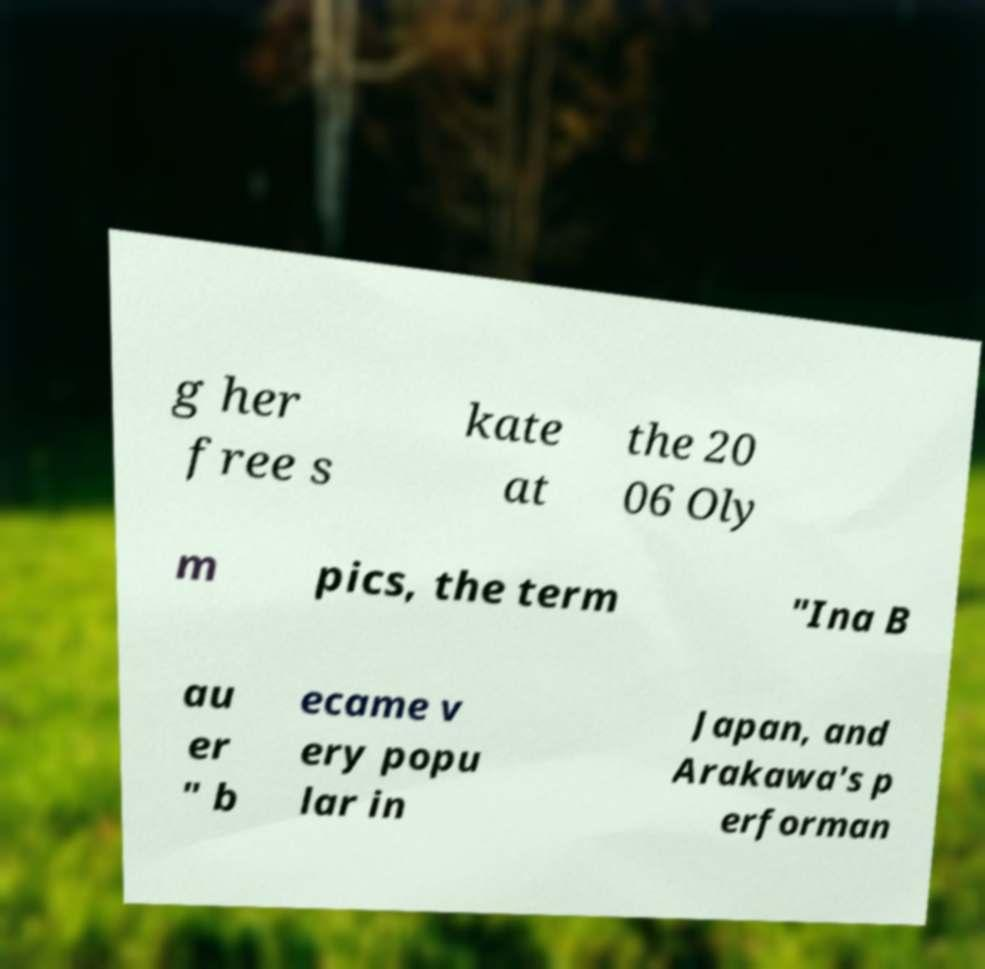Please read and relay the text visible in this image. What does it say? g her free s kate at the 20 06 Oly m pics, the term "Ina B au er " b ecame v ery popu lar in Japan, and Arakawa's p erforman 